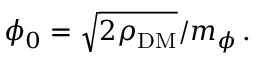Convert formula to latex. <formula><loc_0><loc_0><loc_500><loc_500>\phi _ { 0 } = \sqrt { 2 \rho _ { D M } } / m _ { \phi } \, .</formula> 